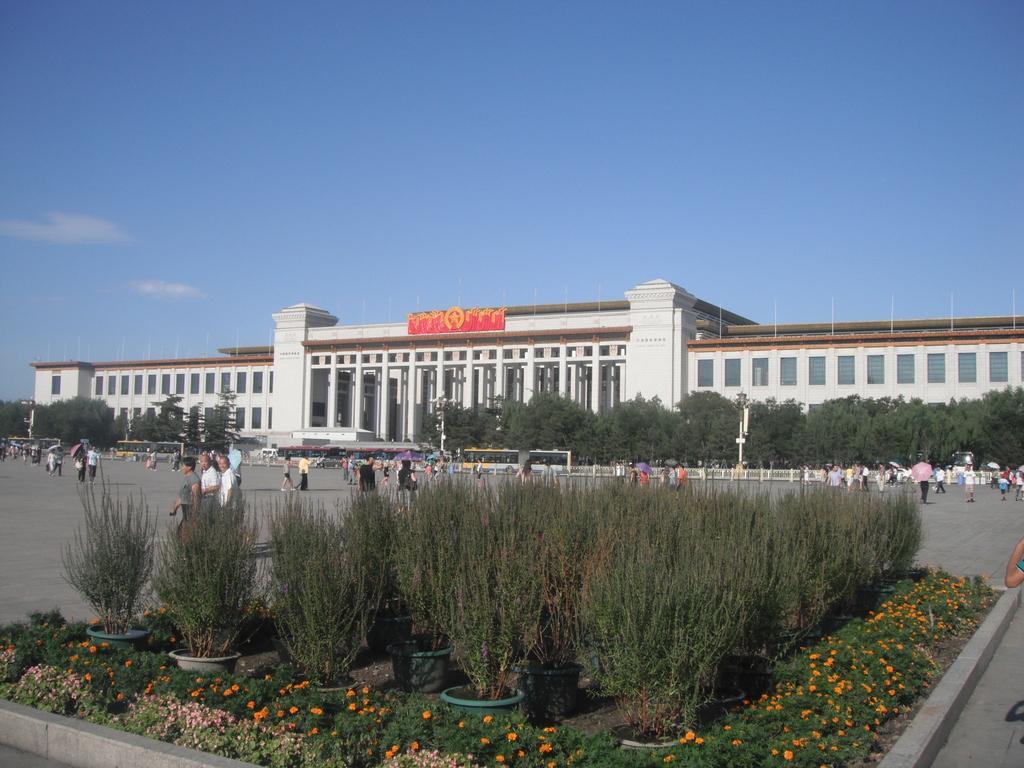In one or two sentences, can you explain what this image depicts? In this image I can see a building in the center of the image and some people on the road in front of the building. At the bottom of the image I can see decorated area with potted plants and other plants. At the top of the image I can see the sky.  